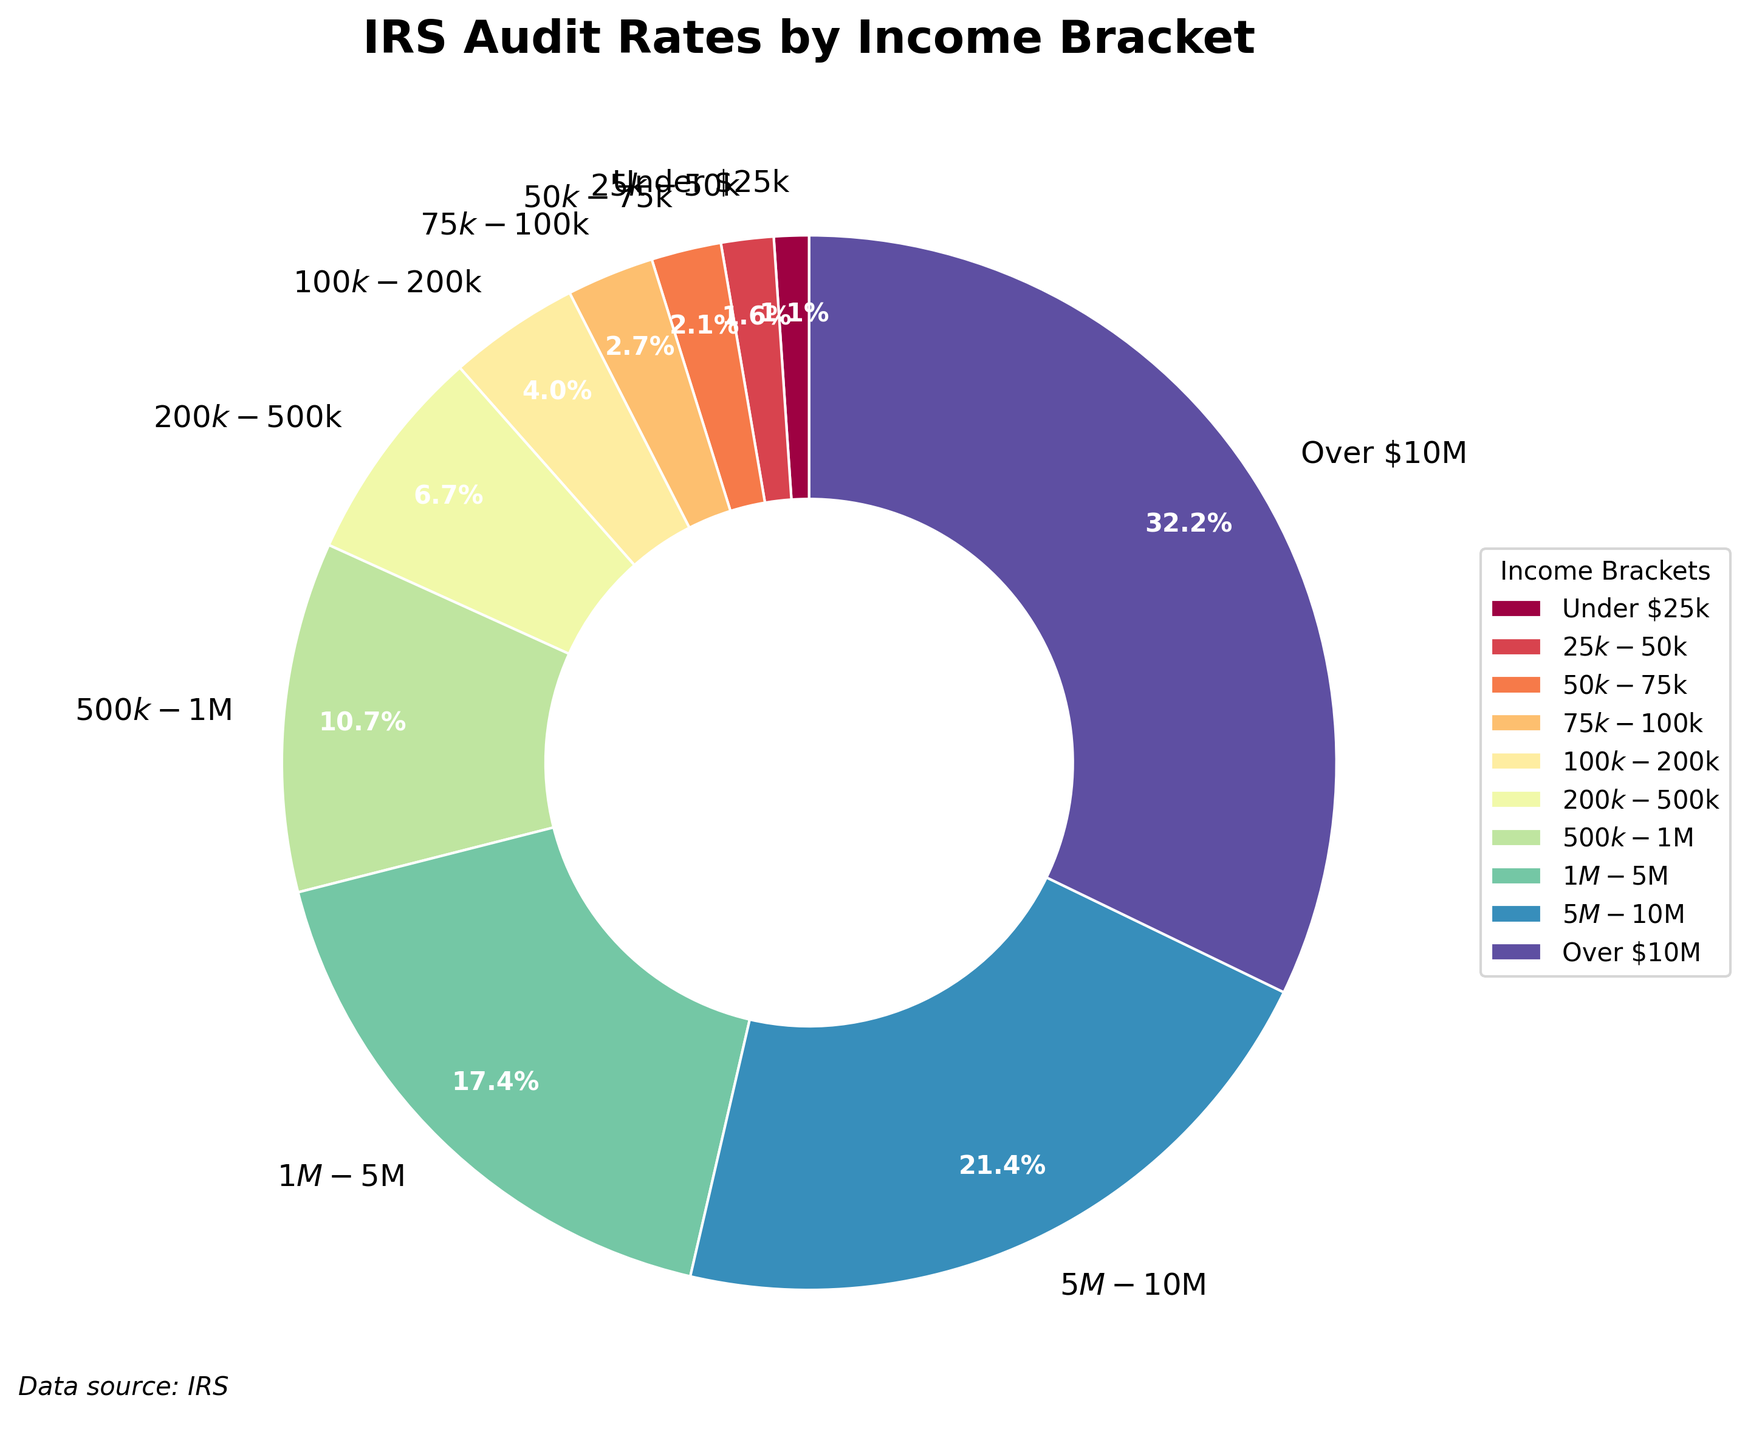What income bracket has the highest audit rate? The wedge that represents the "Over $10M" bracket is the largest in size, and its audit rate is shown as 12.0%, which is the highest among all brackets.
Answer: Over $10M What is the audit rate difference between the $100k-$200k and $200k-$500k income brackets? The audit rate for the $100k-$200k bracket is 1.5%, and for the $200k-$500k bracket, it is 2.5%. Subtracting these values gives the difference: 2.5% - 1.5% = 1.0%.
Answer: 1.0% Which income bracket has an audit rate twice as high as the $50k-$75k bracket? The audit rate for the $50k-$75k bracket is 0.8%. Looking for an audit rate twice as high, we calculate 0.8% * 2 = 1.6%. The closest higher bracket is the $100k-$200k with 1.5%, but this is not exactly double.
Answer: None What percentage of audits are for income brackets under $100k? Summing the audit rates for income brackets "Under $25k," "$25k-$50k," "$50k-$75k," "$75k-$100k" gives: 0.4% + 0.6% + 0.8% + 1.0% = 2.8%.
Answer: 2.8% Which income bracket has the smallest audit rate, and what is it? The smallest wedge in the pie chart belongs to the "Under $25k" income bracket, with an audit rate of 0.4%.
Answer: Under $25k, 0.4% How does the audit rate for the $500k-$1M bracket compare to the $1M-$5M bracket? The audit rate for the $500k-$1M bracket is 4.0%, while for the $1M-$5M bracket, it is 6.5%. Comparing these, 6.5% is greater than 4.0%.
Answer: $1M-$5M bracket has a higher rate What is the total audit rate for all income brackets over $1M? Summing the audit rates for "$1M-$5M," "$5M-$10M," and "Over $10M" gives: 6.5% + 8.0% + 12.0% = 26.5%.
Answer: 26.5% What's the average audit rate for income brackets between $25k and $500k? Averaging the audit rates for "$25k-$50k," "$50k-$75k," "$75k-$100k," "$100k-$200k," and "$200k-$500k,": (0.6% + 0.8% + 1.0% + 1.5% + 2.5%) / 5 = 6.4% / 5 = 1.28%.
Answer: 1.28% 